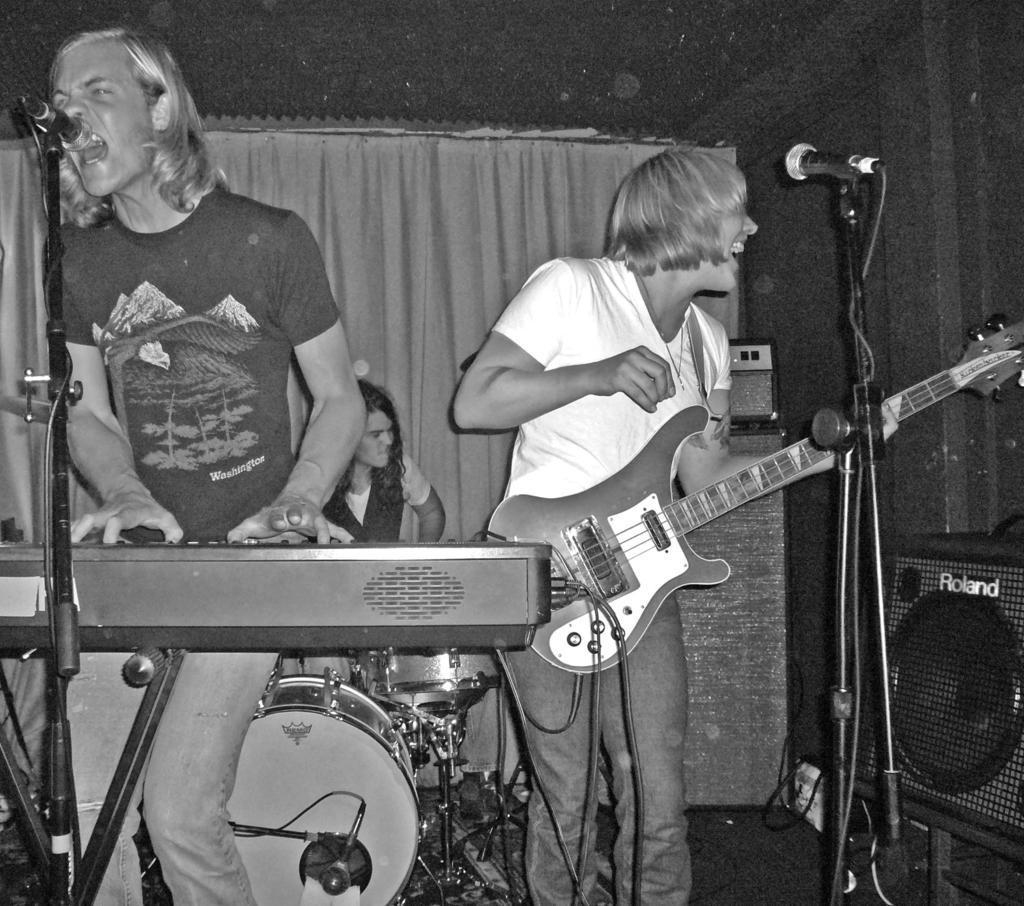Please provide a concise description of this image. In the picture we can find two men are standing, one man is singing in the microphone and and playing keyboard and the other person just aside to him holding a guitar and singing in the micro phone. In the background we can find a person sitting and playing a drums and just behind him we can find a curtain. 